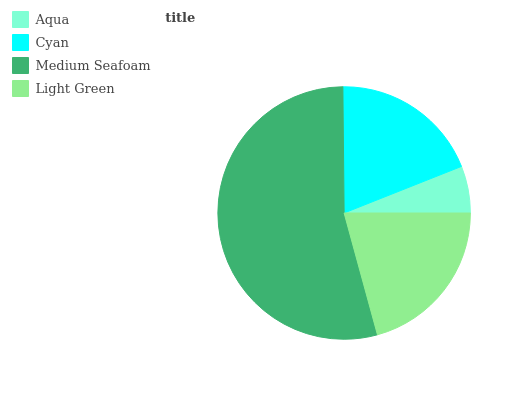Is Aqua the minimum?
Answer yes or no. Yes. Is Medium Seafoam the maximum?
Answer yes or no. Yes. Is Cyan the minimum?
Answer yes or no. No. Is Cyan the maximum?
Answer yes or no. No. Is Cyan greater than Aqua?
Answer yes or no. Yes. Is Aqua less than Cyan?
Answer yes or no. Yes. Is Aqua greater than Cyan?
Answer yes or no. No. Is Cyan less than Aqua?
Answer yes or no. No. Is Light Green the high median?
Answer yes or no. Yes. Is Cyan the low median?
Answer yes or no. Yes. Is Medium Seafoam the high median?
Answer yes or no. No. Is Medium Seafoam the low median?
Answer yes or no. No. 